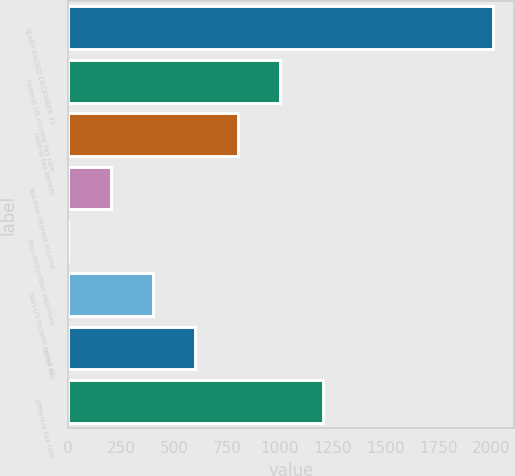Convert chart to OTSL. <chart><loc_0><loc_0><loc_500><loc_500><bar_chart><fcel>YEARS ENDED DECEMBER 31<fcel>Federal US income tax rate<fcel>federal tax benefit<fcel>Tax-free interest income<fcel>Non-deductible expenses<fcel>Non-US income taxed at<fcel>Other net<fcel>Effective tax rate<nl><fcel>2005<fcel>1002.65<fcel>802.18<fcel>200.77<fcel>0.3<fcel>401.24<fcel>601.71<fcel>1203.12<nl></chart> 